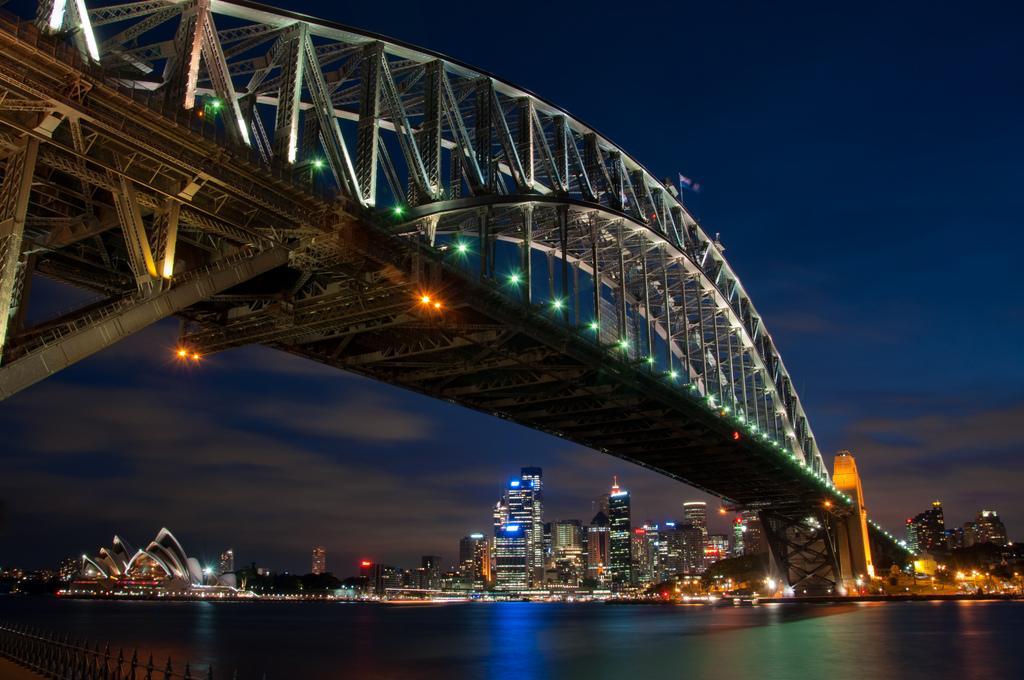How would you summarize this image in a sentence or two? This is an image clicked in the dark. In this image I can see a bridge. In the background there are many buildings along with the lights. In the bottom left-hand corner there is a railing. At the top of the image I can see the sky. 